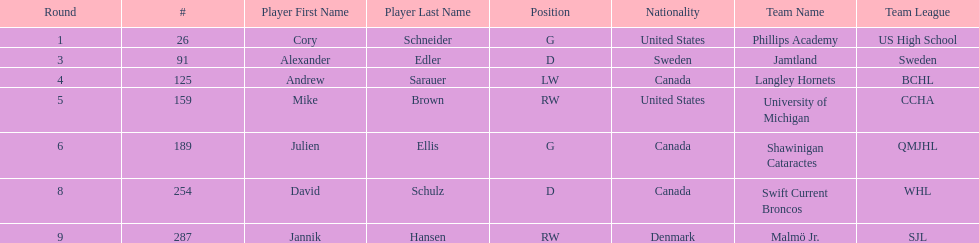Which player was the first player to be drafted? Cory Schneider (G). 